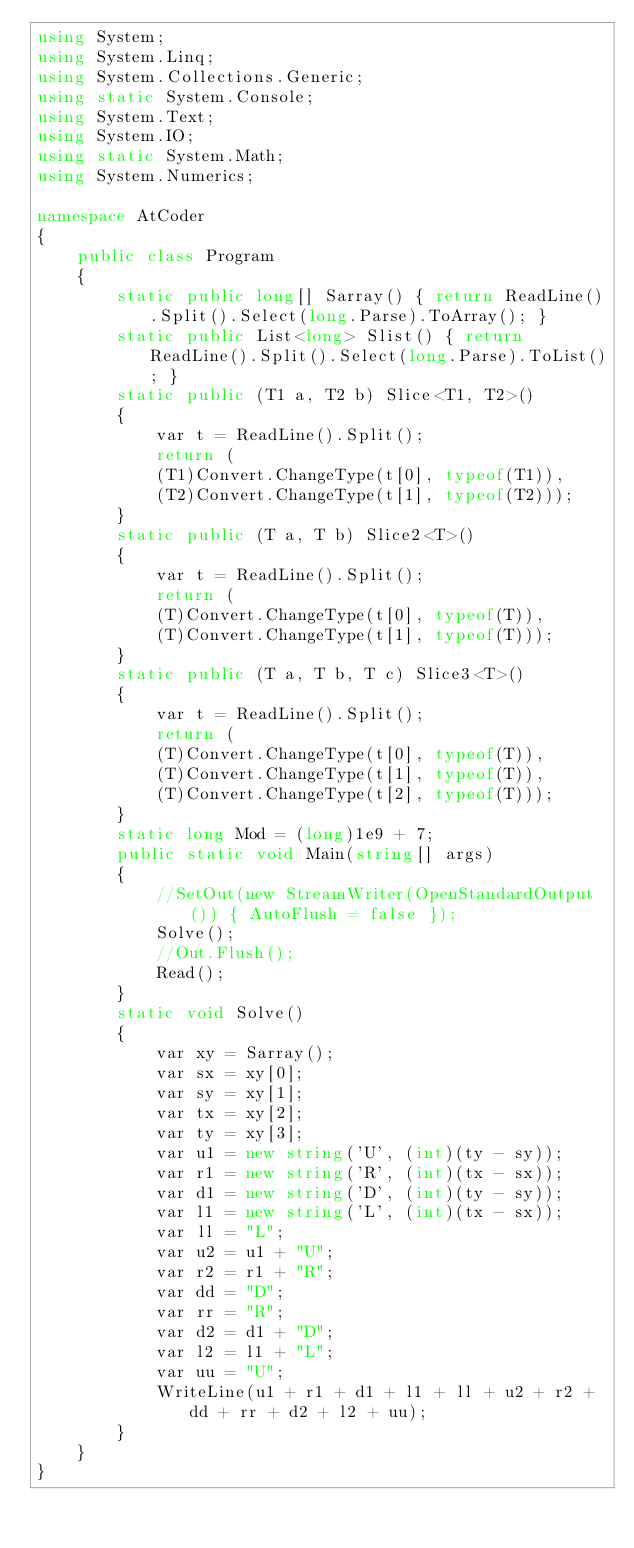<code> <loc_0><loc_0><loc_500><loc_500><_C#_>using System;
using System.Linq;
using System.Collections.Generic;
using static System.Console;
using System.Text;
using System.IO;
using static System.Math;
using System.Numerics;

namespace AtCoder
{
    public class Program
    {
        static public long[] Sarray() { return ReadLine().Split().Select(long.Parse).ToArray(); }
        static public List<long> Slist() { return ReadLine().Split().Select(long.Parse).ToList(); }
        static public (T1 a, T2 b) Slice<T1, T2>()
        {
            var t = ReadLine().Split();
            return (
            (T1)Convert.ChangeType(t[0], typeof(T1)),
            (T2)Convert.ChangeType(t[1], typeof(T2)));
        }
        static public (T a, T b) Slice2<T>()
        {
            var t = ReadLine().Split();
            return (
            (T)Convert.ChangeType(t[0], typeof(T)),
            (T)Convert.ChangeType(t[1], typeof(T)));
        }
        static public (T a, T b, T c) Slice3<T>()
        {
            var t = ReadLine().Split();
            return (
            (T)Convert.ChangeType(t[0], typeof(T)),
            (T)Convert.ChangeType(t[1], typeof(T)),
            (T)Convert.ChangeType(t[2], typeof(T)));
        }
        static long Mod = (long)1e9 + 7;
        public static void Main(string[] args)
        {
            //SetOut(new StreamWriter(OpenStandardOutput()) { AutoFlush = false });
            Solve();
            //Out.Flush();
            Read();
        }
        static void Solve()
        {
            var xy = Sarray();
            var sx = xy[0];
            var sy = xy[1];
            var tx = xy[2];
            var ty = xy[3];
            var u1 = new string('U', (int)(ty - sy));
            var r1 = new string('R', (int)(tx - sx));
            var d1 = new string('D', (int)(ty - sy));
            var l1 = new string('L', (int)(tx - sx));
            var ll = "L";
            var u2 = u1 + "U";
            var r2 = r1 + "R";
            var dd = "D";
            var rr = "R";
            var d2 = d1 + "D";
            var l2 = l1 + "L";
            var uu = "U";
            WriteLine(u1 + r1 + d1 + l1 + ll + u2 + r2 + dd + rr + d2 + l2 + uu);
        }
    }
}</code> 